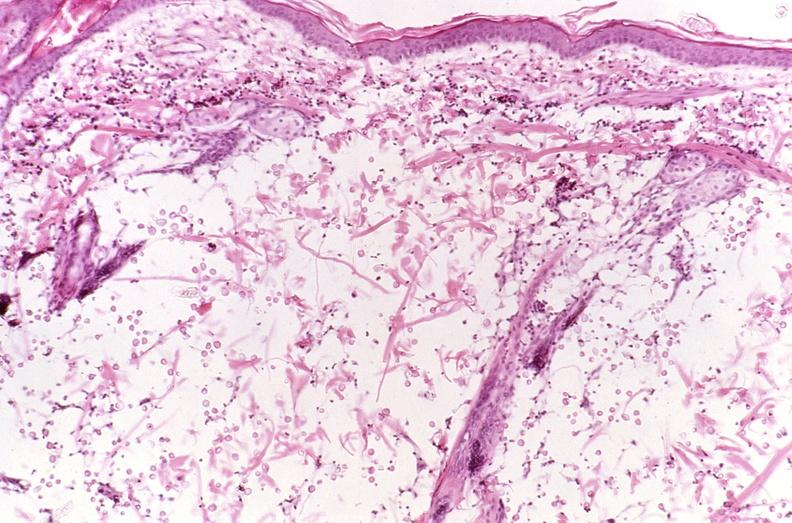what does this image show?
Answer the question using a single word or phrase. Cryptococcal dematitis 